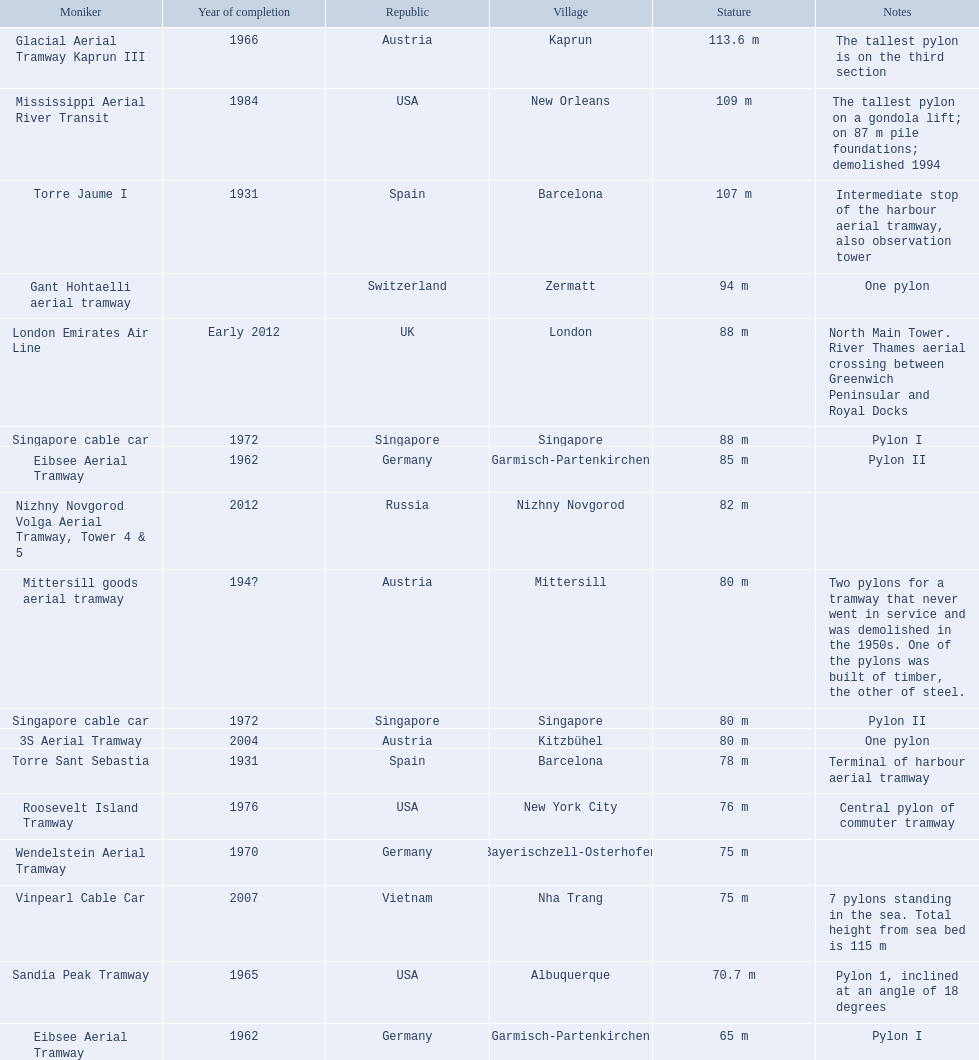How many aerial lift pylon's on the list are located in the usa? Mississippi Aerial River Transit, Roosevelt Island Tramway, Sandia Peak Tramway. Of the pylon's located in the usa how many were built after 1970? Mississippi Aerial River Transit, Roosevelt Island Tramway. Of the pylon's built after 1970 which is the tallest pylon on a gondola lift? Mississippi Aerial River Transit. How many meters is the tallest pylon on a gondola lift? 109 m. 